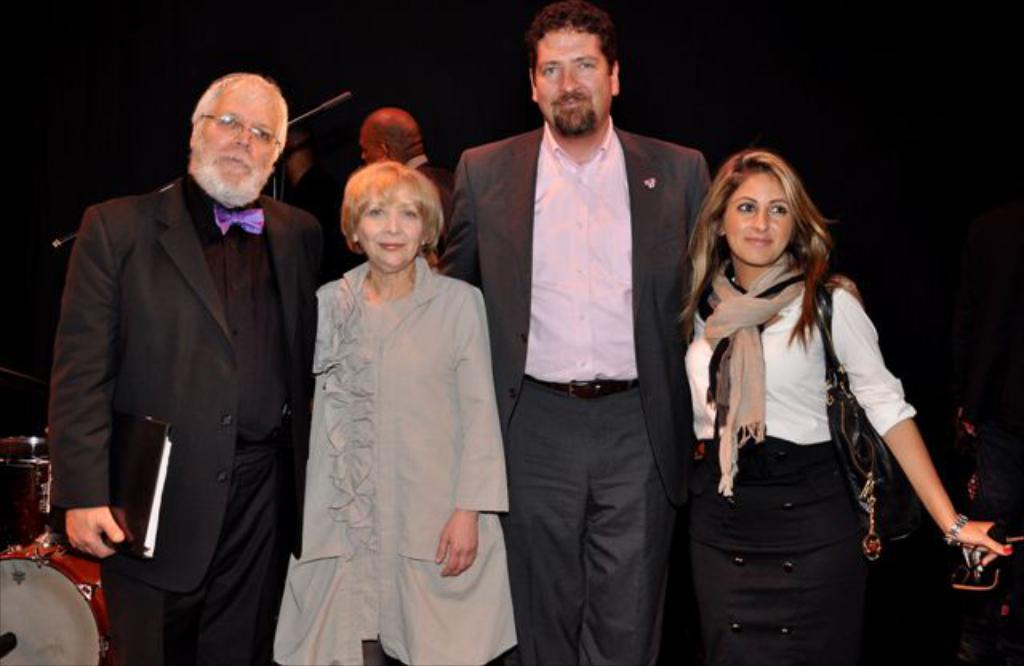Describe this image in one or two sentences. In this picture I can see people standing. I can see drum set on the left side in the background. I can see man on the left side holding a book and wearing spectacle. 